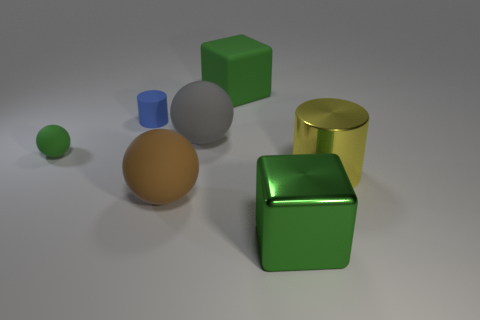Could you tell me which objects in the image are casting shadows, and how the light source direction might be inferred? Each object in the image is casting a shadow, suggesting the presence of a light source above and to the left of the scene. The shadows help indicate the spatial relationship between objects and their size relative to each other. 